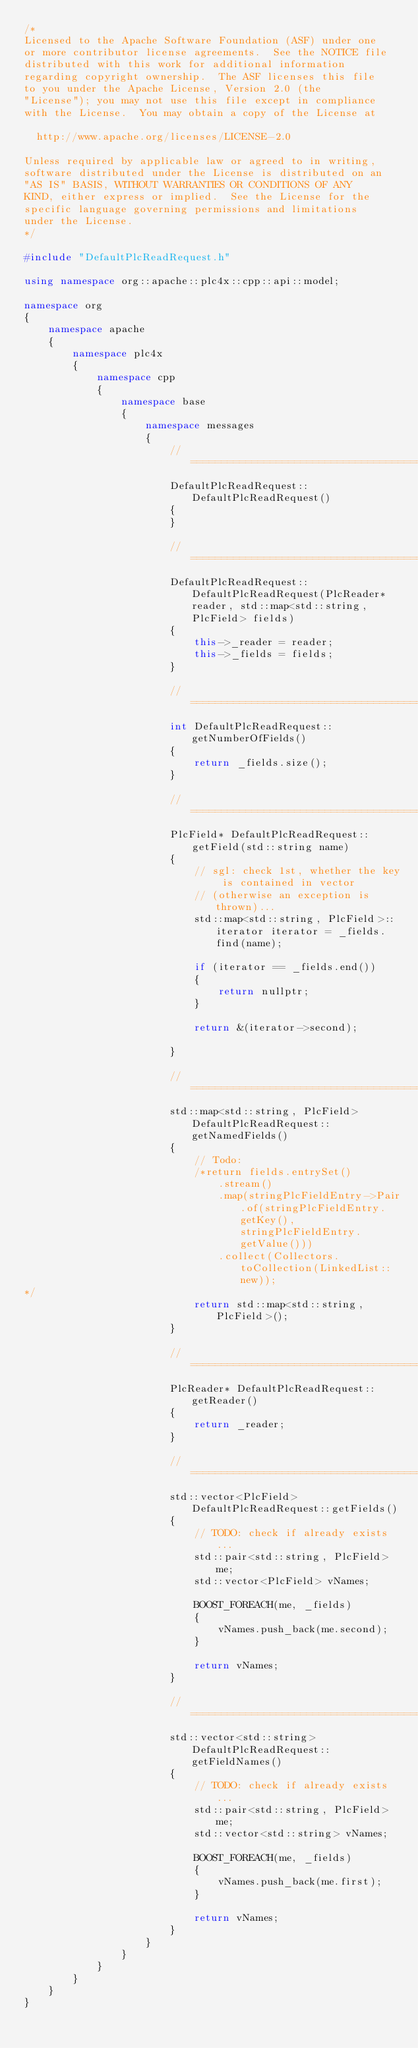<code> <loc_0><loc_0><loc_500><loc_500><_C++_>/*
Licensed to the Apache Software Foundation (ASF) under one
or more contributor license agreements.  See the NOTICE file
distributed with this work for additional information
regarding copyright ownership.  The ASF licenses this file
to you under the Apache License, Version 2.0 (the
"License"); you may not use this file except in compliance
with the License.  You may obtain a copy of the License at

  http://www.apache.org/licenses/LICENSE-2.0

Unless required by applicable law or agreed to in writing,
software distributed under the License is distributed on an
"AS IS" BASIS, WITHOUT WARRANTIES OR CONDITIONS OF ANY
KIND, either express or implied.  See the License for the
specific language governing permissions and limitations
under the License.
*/

#include "DefaultPlcReadRequest.h"

using namespace org::apache::plc4x::cpp::api::model;

namespace org
{
	namespace apache
	{
		namespace plc4x
		{
			namespace cpp
			{
				namespace base
				{
					namespace messages
					{
						// =========================================================
						DefaultPlcReadRequest::DefaultPlcReadRequest()
						{
						}

						// =========================================================
						DefaultPlcReadRequest::DefaultPlcReadRequest(PlcReader* reader, std::map<std::string, PlcField> fields)
						{
							this->_reader = reader;
							this->_fields = fields;
						}

						// ==========================================================
						int DefaultPlcReadRequest::getNumberOfFields()
						{
							return _fields.size();
						}

						// =========================================================
						PlcField* DefaultPlcReadRequest::getField(std::string name)
						{
							// sgl: check 1st, whether the key is contained in vector 
							// (otherwise an exception is thrown)...
							std::map<std::string, PlcField>::iterator iterator = _fields.find(name);

							if (iterator == _fields.end())
							{
								return nullptr;
							}

							return &(iterator->second);
							
						}

						// ======================================================
						std::map<std::string, PlcField> DefaultPlcReadRequest::getNamedFields()
						{
							// Todo:
							/*return fields.entrySet()
								.stream()
								.map(stringPlcFieldEntry->Pair.of(stringPlcFieldEntry.getKey(), stringPlcFieldEntry.getValue()))
								.collect(Collectors.toCollection(LinkedList::new));
*/
							return std::map<std::string, PlcField>();
						}

						// ====================================================
						PlcReader* DefaultPlcReadRequest::getReader()
						{
							return _reader;
						}

						// =====================================================
						std::vector<PlcField> DefaultPlcReadRequest::getFields()
						{
							// TODO: check if already exists...
							std::pair<std::string, PlcField> me;
							std::vector<PlcField> vNames;

							BOOST_FOREACH(me, _fields)
							{
								vNames.push_back(me.second);
							}

							return vNames;
						}

						// =========================================================
						std::vector<std::string> DefaultPlcReadRequest::getFieldNames()
						{							
							// TODO: check if already exists...
							std::pair<std::string, PlcField> me;
							std::vector<std::string> vNames;

							BOOST_FOREACH(me, _fields)
							{
								vNames.push_back(me.first);
							}

							return vNames;
						}						
					}
				}
			}
		}
	}
}
</code> 